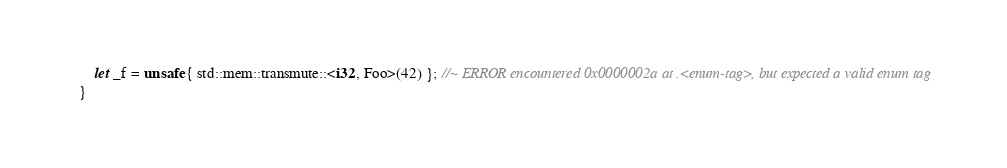Convert code to text. <code><loc_0><loc_0><loc_500><loc_500><_Rust_>    let _f = unsafe { std::mem::transmute::<i32, Foo>(42) }; //~ ERROR encountered 0x0000002a at .<enum-tag>, but expected a valid enum tag
}
</code> 